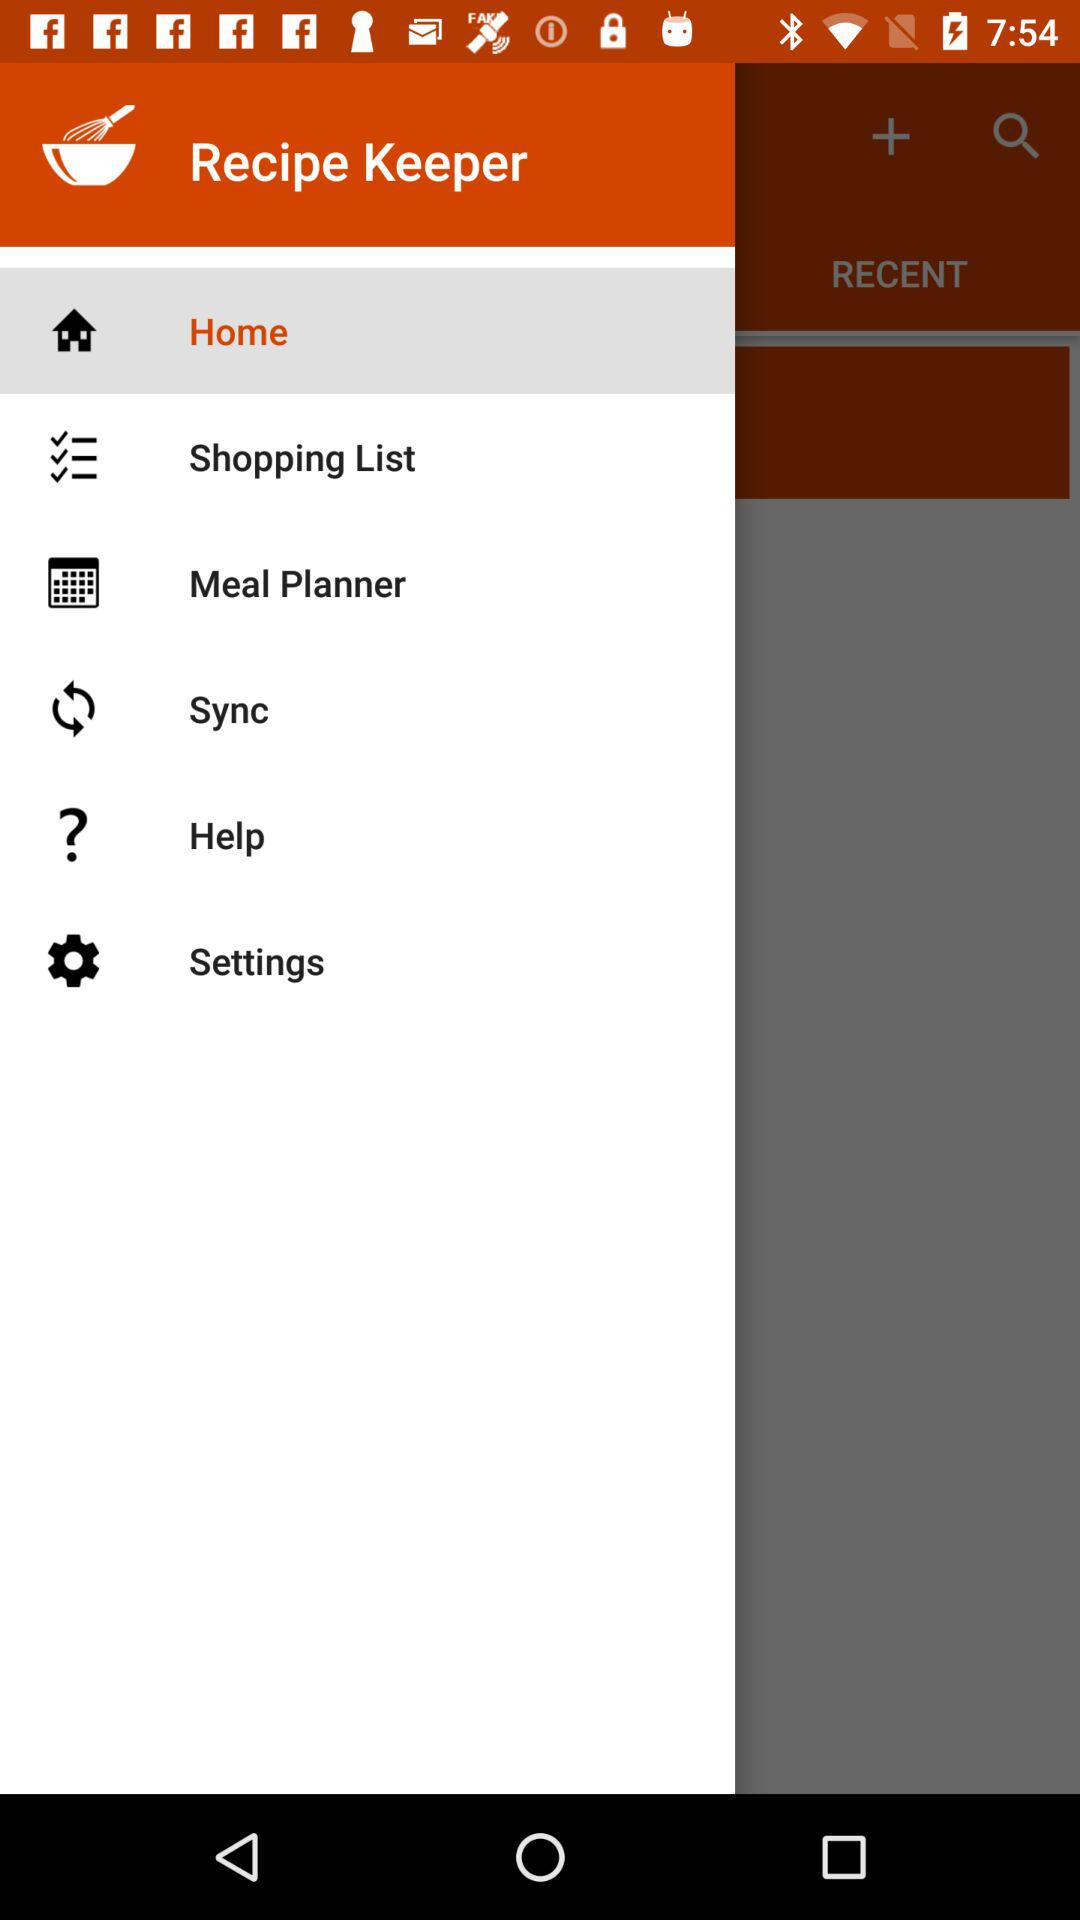What is the selected option? The selected option is "Home". 